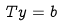<formula> <loc_0><loc_0><loc_500><loc_500>T y = b</formula> 